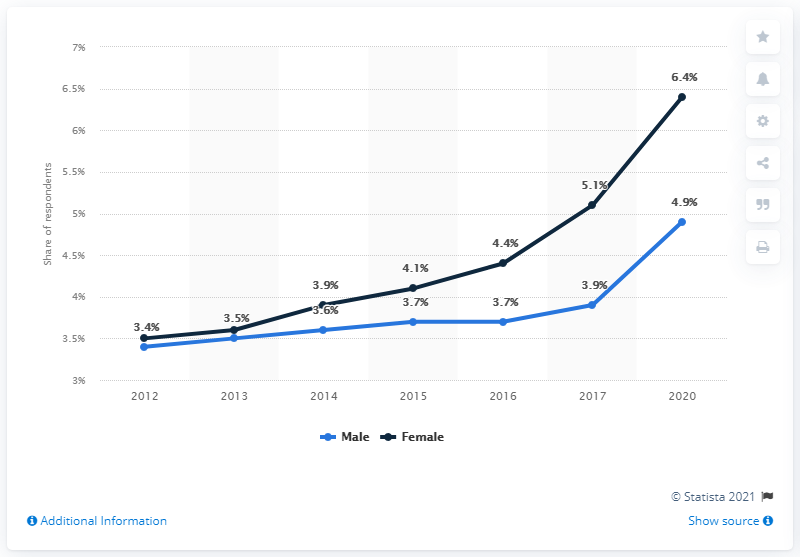Mention a couple of crucial points in this snapshot. In 2012, 3.5% of female respondents self-identified as LGBT. In 2020, 6.4% of female respondents identified as LGBT. In 2012, 3.5% of female respondents and 3.4% of male respondents identified as LGBT. 